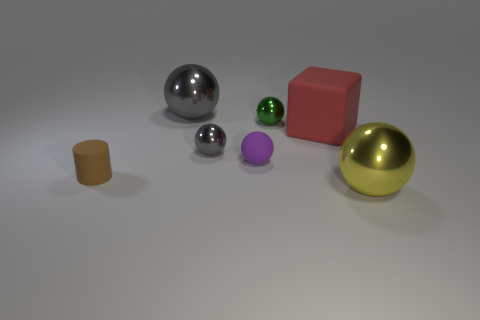Can you describe the lighting used in this scene? The lighting in the image is soft and diffused, with gentle shadows indicating an overhead or a wide-angle light source, creating a calm and controlled indoor environment. 